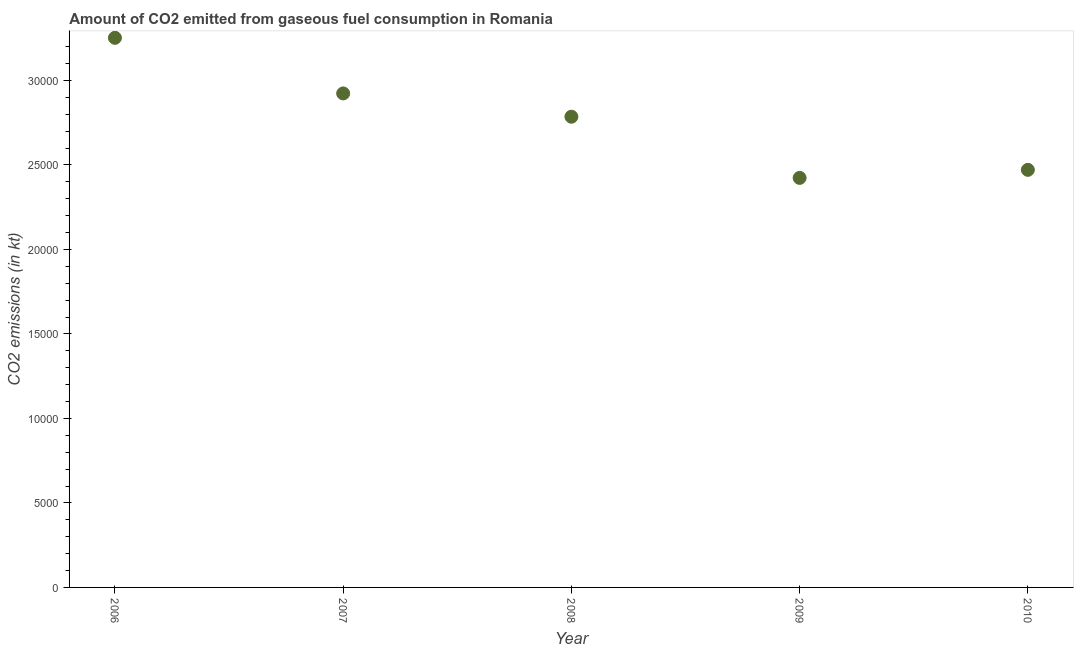What is the co2 emissions from gaseous fuel consumption in 2009?
Provide a short and direct response. 2.42e+04. Across all years, what is the maximum co2 emissions from gaseous fuel consumption?
Your response must be concise. 3.25e+04. Across all years, what is the minimum co2 emissions from gaseous fuel consumption?
Your answer should be compact. 2.42e+04. What is the sum of the co2 emissions from gaseous fuel consumption?
Your answer should be compact. 1.39e+05. What is the difference between the co2 emissions from gaseous fuel consumption in 2006 and 2007?
Offer a very short reply. 3289.3. What is the average co2 emissions from gaseous fuel consumption per year?
Your answer should be very brief. 2.77e+04. What is the median co2 emissions from gaseous fuel consumption?
Your answer should be very brief. 2.79e+04. In how many years, is the co2 emissions from gaseous fuel consumption greater than 1000 kt?
Ensure brevity in your answer.  5. What is the ratio of the co2 emissions from gaseous fuel consumption in 2007 to that in 2008?
Make the answer very short. 1.05. What is the difference between the highest and the second highest co2 emissions from gaseous fuel consumption?
Your response must be concise. 3289.3. What is the difference between the highest and the lowest co2 emissions from gaseous fuel consumption?
Ensure brevity in your answer.  8287.42. Does the co2 emissions from gaseous fuel consumption monotonically increase over the years?
Give a very brief answer. No. How many dotlines are there?
Offer a very short reply. 1. What is the difference between two consecutive major ticks on the Y-axis?
Offer a very short reply. 5000. Does the graph contain any zero values?
Your response must be concise. No. Does the graph contain grids?
Give a very brief answer. No. What is the title of the graph?
Your answer should be very brief. Amount of CO2 emitted from gaseous fuel consumption in Romania. What is the label or title of the X-axis?
Your answer should be very brief. Year. What is the label or title of the Y-axis?
Offer a terse response. CO2 emissions (in kt). What is the CO2 emissions (in kt) in 2006?
Your response must be concise. 3.25e+04. What is the CO2 emissions (in kt) in 2007?
Keep it short and to the point. 2.92e+04. What is the CO2 emissions (in kt) in 2008?
Your answer should be compact. 2.79e+04. What is the CO2 emissions (in kt) in 2009?
Offer a terse response. 2.42e+04. What is the CO2 emissions (in kt) in 2010?
Offer a very short reply. 2.47e+04. What is the difference between the CO2 emissions (in kt) in 2006 and 2007?
Offer a terse response. 3289.3. What is the difference between the CO2 emissions (in kt) in 2006 and 2008?
Provide a short and direct response. 4668.09. What is the difference between the CO2 emissions (in kt) in 2006 and 2009?
Your response must be concise. 8287.42. What is the difference between the CO2 emissions (in kt) in 2006 and 2010?
Provide a short and direct response. 7810.71. What is the difference between the CO2 emissions (in kt) in 2007 and 2008?
Offer a very short reply. 1378.79. What is the difference between the CO2 emissions (in kt) in 2007 and 2009?
Keep it short and to the point. 4998.12. What is the difference between the CO2 emissions (in kt) in 2007 and 2010?
Keep it short and to the point. 4521.41. What is the difference between the CO2 emissions (in kt) in 2008 and 2009?
Your answer should be compact. 3619.33. What is the difference between the CO2 emissions (in kt) in 2008 and 2010?
Provide a succinct answer. 3142.62. What is the difference between the CO2 emissions (in kt) in 2009 and 2010?
Offer a terse response. -476.71. What is the ratio of the CO2 emissions (in kt) in 2006 to that in 2007?
Give a very brief answer. 1.11. What is the ratio of the CO2 emissions (in kt) in 2006 to that in 2008?
Provide a succinct answer. 1.17. What is the ratio of the CO2 emissions (in kt) in 2006 to that in 2009?
Give a very brief answer. 1.34. What is the ratio of the CO2 emissions (in kt) in 2006 to that in 2010?
Ensure brevity in your answer.  1.32. What is the ratio of the CO2 emissions (in kt) in 2007 to that in 2008?
Ensure brevity in your answer.  1.05. What is the ratio of the CO2 emissions (in kt) in 2007 to that in 2009?
Make the answer very short. 1.21. What is the ratio of the CO2 emissions (in kt) in 2007 to that in 2010?
Offer a terse response. 1.18. What is the ratio of the CO2 emissions (in kt) in 2008 to that in 2009?
Offer a very short reply. 1.15. What is the ratio of the CO2 emissions (in kt) in 2008 to that in 2010?
Provide a succinct answer. 1.13. 